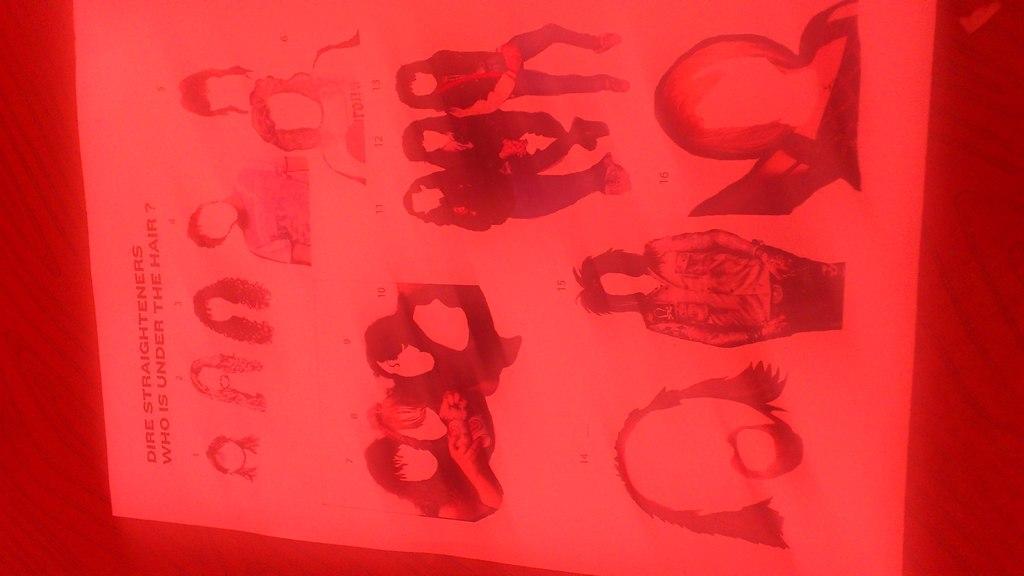Please provide a concise description of this image. Here we can see poster,in this poster we can see persons. 